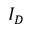<formula> <loc_0><loc_0><loc_500><loc_500>I _ { D }</formula> 